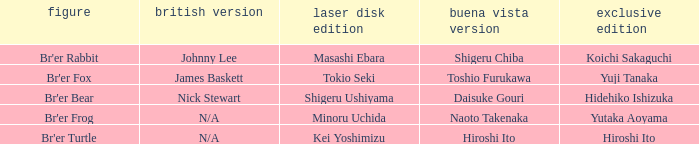What is the special edition where the english version is nick stewart? Hidehiko Ishizuka. 